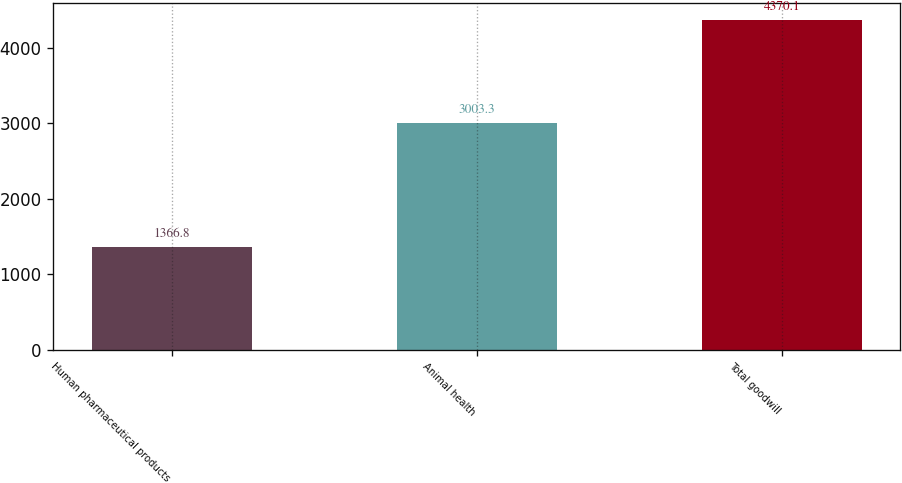<chart> <loc_0><loc_0><loc_500><loc_500><bar_chart><fcel>Human pharmaceutical products<fcel>Animal health<fcel>Total goodwill<nl><fcel>1366.8<fcel>3003.3<fcel>4370.1<nl></chart> 